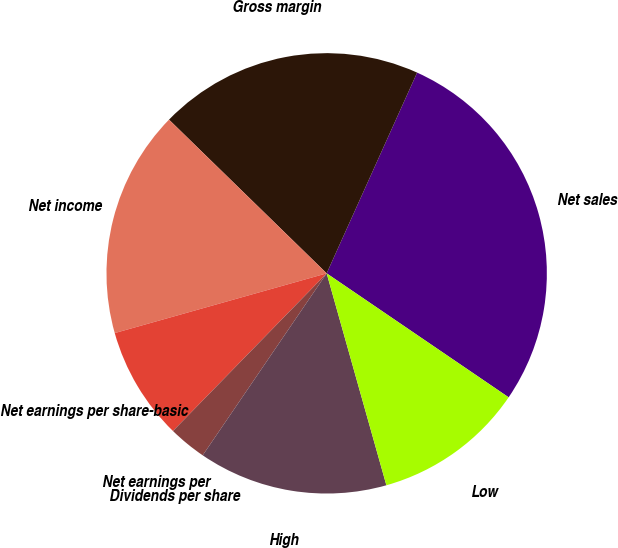Convert chart to OTSL. <chart><loc_0><loc_0><loc_500><loc_500><pie_chart><fcel>Net sales<fcel>Gross margin<fcel>Net income<fcel>Net earnings per share-basic<fcel>Net earnings per<fcel>Dividends per share<fcel>High<fcel>Low<nl><fcel>27.78%<fcel>19.44%<fcel>16.67%<fcel>8.33%<fcel>2.78%<fcel>0.0%<fcel>13.89%<fcel>11.11%<nl></chart> 